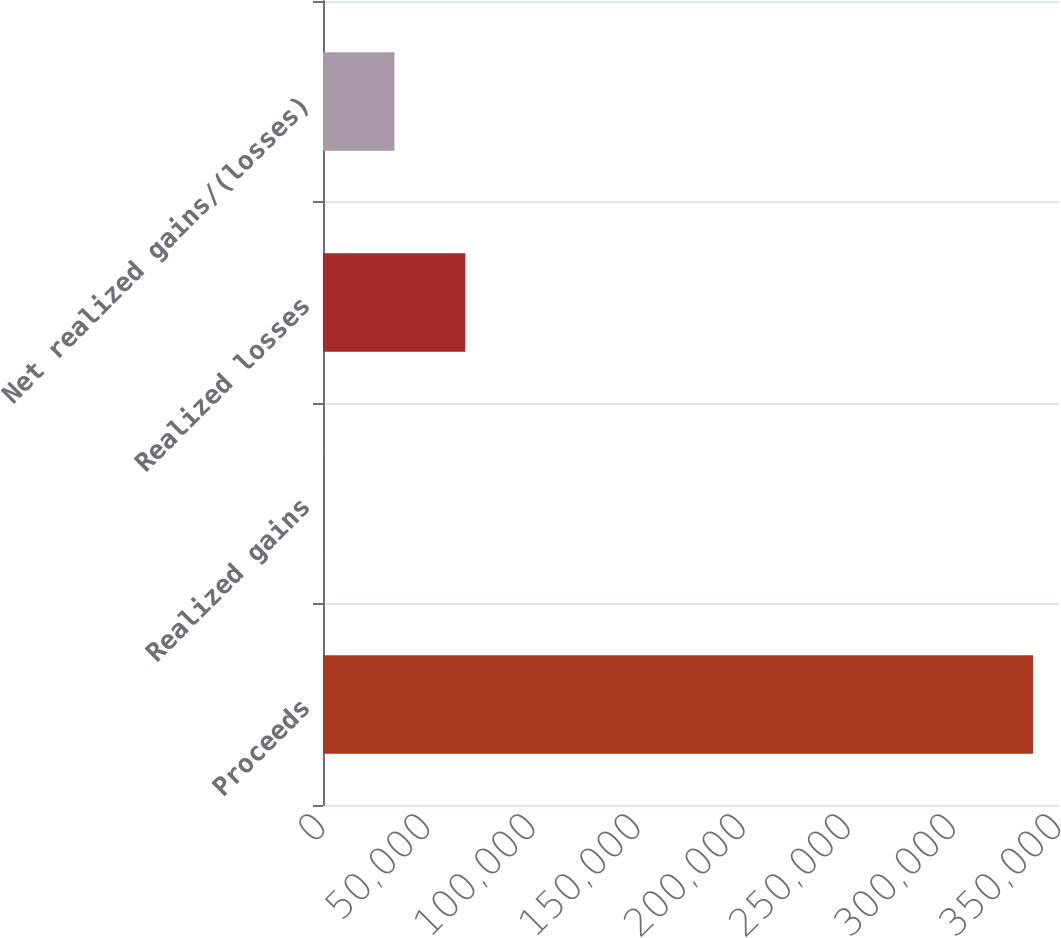Convert chart. <chart><loc_0><loc_0><loc_500><loc_500><bar_chart><fcel>Proceeds<fcel>Realized gains<fcel>Realized losses<fcel>Net realized gains/(losses)<nl><fcel>337671<fcel>215<fcel>67706.2<fcel>33960.6<nl></chart> 